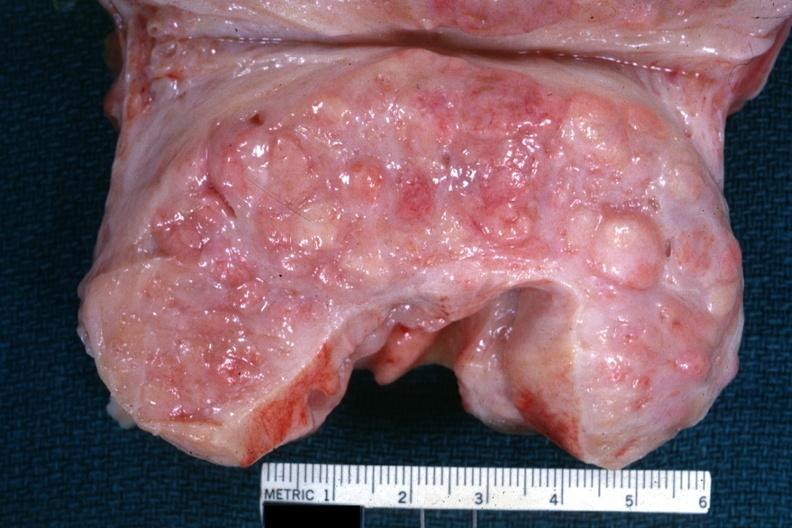how is excellent example cut surface with hyperplasia?
Answer the question using a single word or phrase. Nodular 